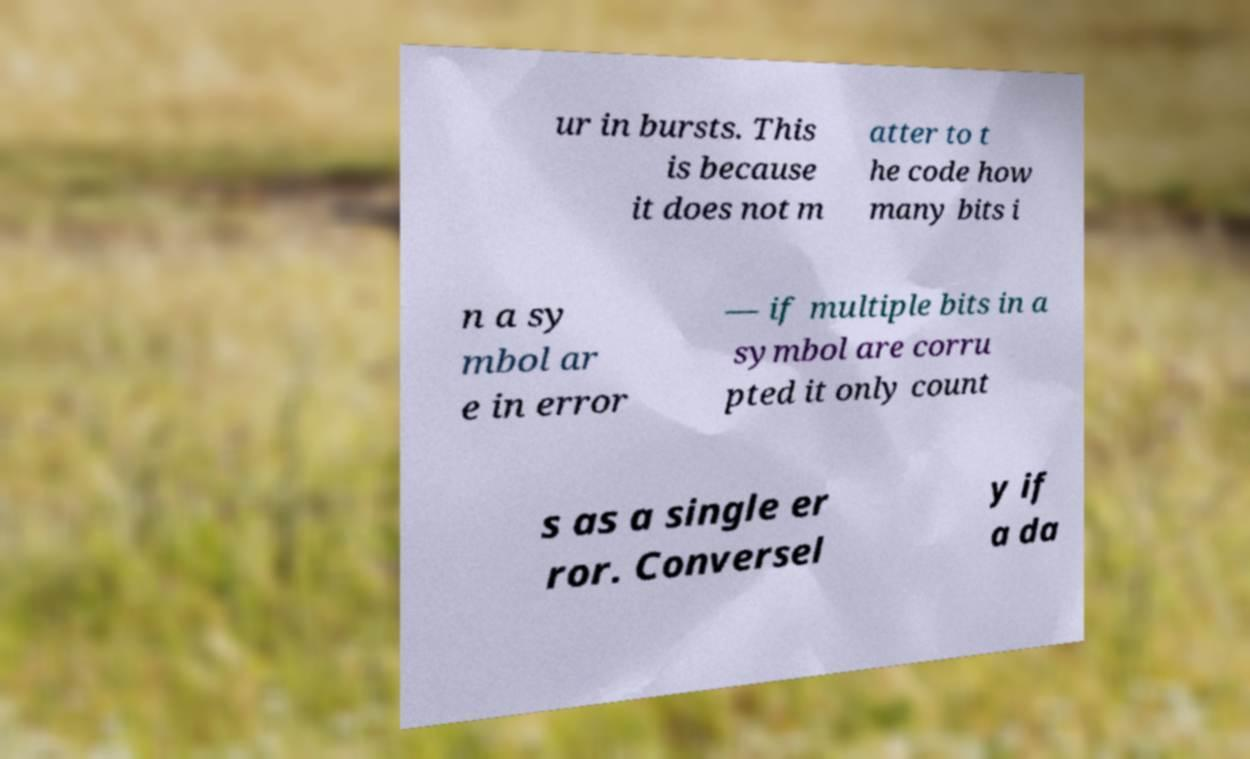Could you extract and type out the text from this image? ur in bursts. This is because it does not m atter to t he code how many bits i n a sy mbol ar e in error — if multiple bits in a symbol are corru pted it only count s as a single er ror. Conversel y if a da 